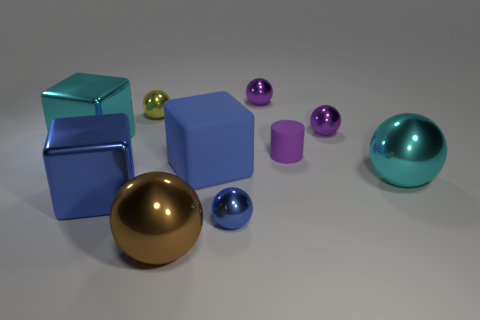Subtract all small yellow spheres. How many spheres are left? 5 Subtract all brown balls. How many blue cubes are left? 2 Subtract all cyan cubes. How many cubes are left? 2 Subtract 3 spheres. How many spheres are left? 3 Subtract all blue balls. Subtract all yellow cylinders. How many balls are left? 5 Subtract all cylinders. How many objects are left? 9 Subtract all rubber blocks. Subtract all tiny matte cylinders. How many objects are left? 8 Add 1 cyan things. How many cyan things are left? 3 Add 4 large yellow metal cubes. How many large yellow metal cubes exist? 4 Subtract 1 cyan blocks. How many objects are left? 9 